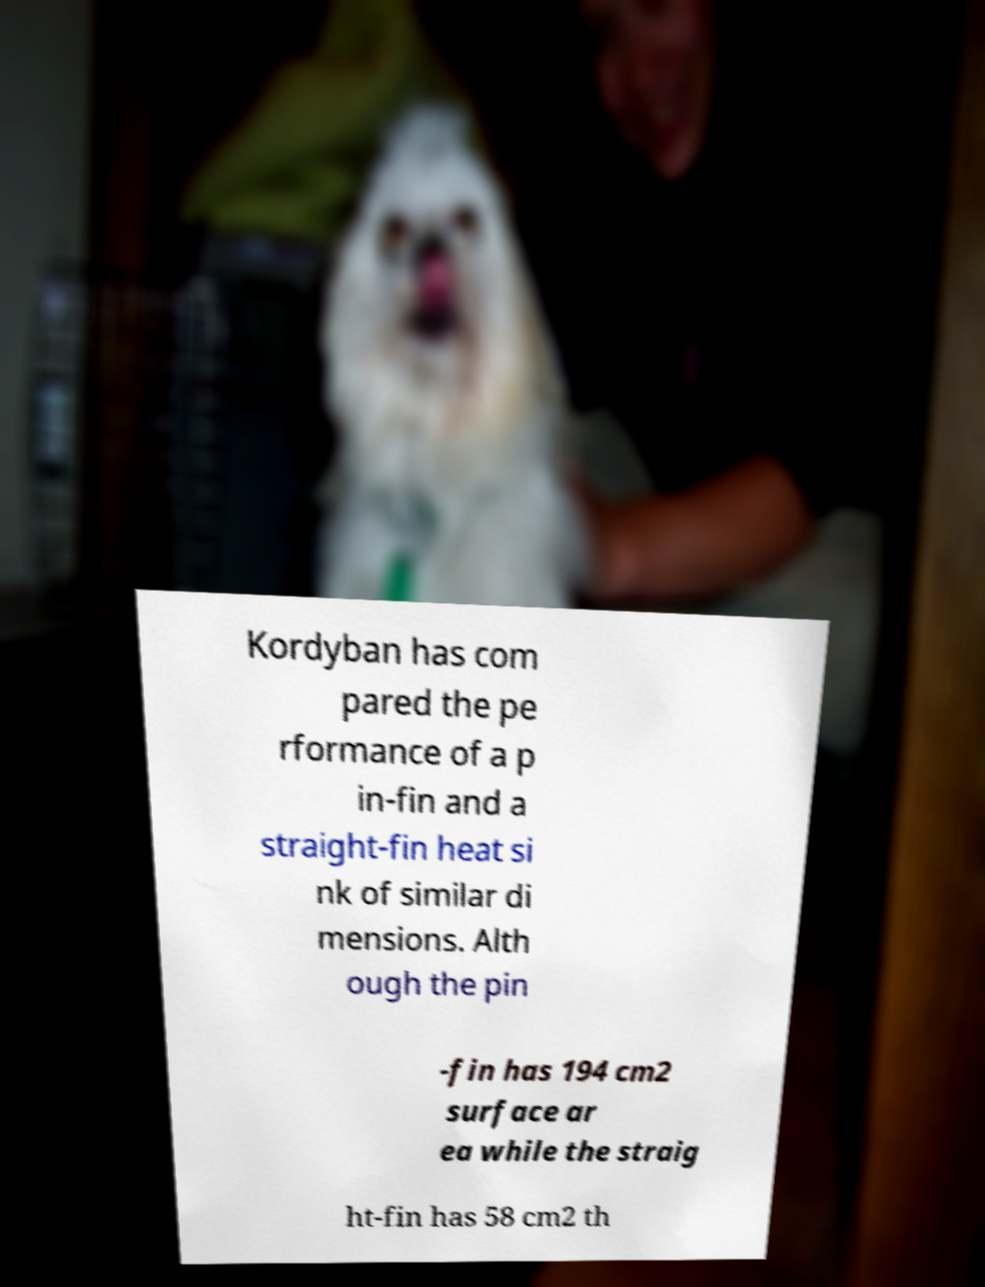Could you assist in decoding the text presented in this image and type it out clearly? Kordyban has com pared the pe rformance of a p in-fin and a straight-fin heat si nk of similar di mensions. Alth ough the pin -fin has 194 cm2 surface ar ea while the straig ht-fin has 58 cm2 th 